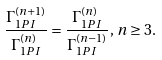Convert formula to latex. <formula><loc_0><loc_0><loc_500><loc_500>\frac { \Gamma ^ { ( n + 1 ) } _ { 1 P I } } { \Gamma ^ { ( n ) } _ { 1 P I } } = \frac { \Gamma ^ { ( n ) } _ { 1 P I } } { \Gamma ^ { ( n - 1 ) } _ { 1 P I } } , \, n \geq 3 .</formula> 